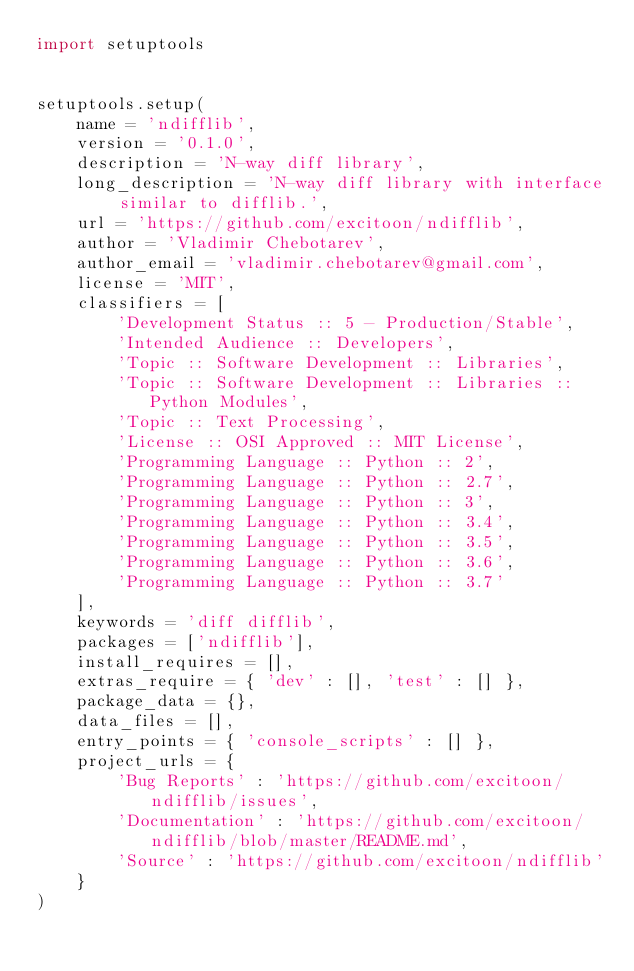<code> <loc_0><loc_0><loc_500><loc_500><_Python_>import setuptools


setuptools.setup(
    name = 'ndifflib',
    version = '0.1.0',
    description = 'N-way diff library',
    long_description = 'N-way diff library with interface similar to difflib.',
    url = 'https://github.com/excitoon/ndifflib',
    author = 'Vladimir Chebotarev',
    author_email = 'vladimir.chebotarev@gmail.com',
    license = 'MIT',
    classifiers = [
        'Development Status :: 5 - Production/Stable',
        'Intended Audience :: Developers',
        'Topic :: Software Development :: Libraries',
        'Topic :: Software Development :: Libraries :: Python Modules',
        'Topic :: Text Processing',
        'License :: OSI Approved :: MIT License',
        'Programming Language :: Python :: 2',
        'Programming Language :: Python :: 2.7',
        'Programming Language :: Python :: 3',
        'Programming Language :: Python :: 3.4',
        'Programming Language :: Python :: 3.5',
        'Programming Language :: Python :: 3.6',
        'Programming Language :: Python :: 3.7'
    ],
    keywords = 'diff difflib',
    packages = ['ndifflib'],
    install_requires = [],
    extras_require = { 'dev' : [], 'test' : [] },
    package_data = {},
    data_files = [],
    entry_points = { 'console_scripts' : [] },
    project_urls = {
        'Bug Reports' : 'https://github.com/excitoon/ndifflib/issues',
        'Documentation' : 'https://github.com/excitoon/ndifflib/blob/master/README.md',
        'Source' : 'https://github.com/excitoon/ndifflib'
    }
)
</code> 